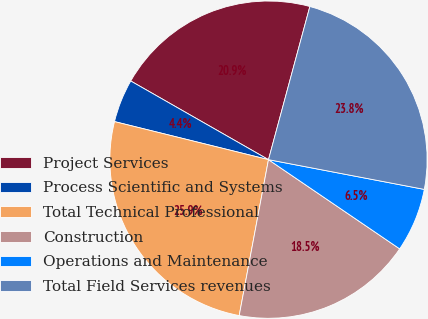Convert chart. <chart><loc_0><loc_0><loc_500><loc_500><pie_chart><fcel>Project Services<fcel>Process Scientific and Systems<fcel>Total Technical Professional<fcel>Construction<fcel>Operations and Maintenance<fcel>Total Field Services revenues<nl><fcel>20.94%<fcel>4.4%<fcel>25.9%<fcel>18.45%<fcel>6.5%<fcel>23.8%<nl></chart> 